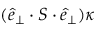Convert formula to latex. <formula><loc_0><loc_0><loc_500><loc_500>( \hat { e } _ { \perp } \cdot S \cdot \hat { e } _ { \perp } ) \kappa</formula> 